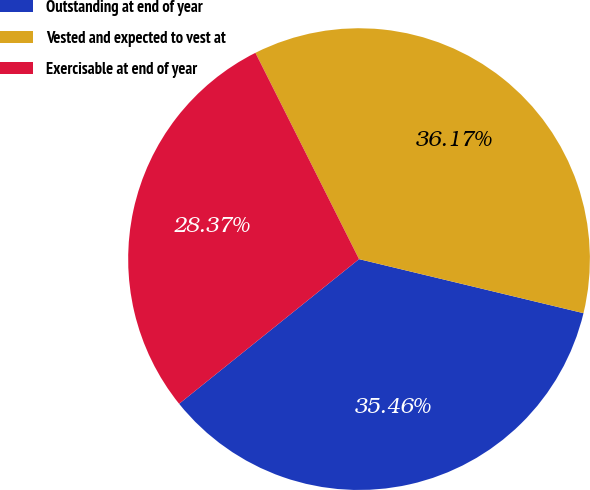Convert chart. <chart><loc_0><loc_0><loc_500><loc_500><pie_chart><fcel>Outstanding at end of year<fcel>Vested and expected to vest at<fcel>Exercisable at end of year<nl><fcel>35.46%<fcel>36.17%<fcel>28.37%<nl></chart> 